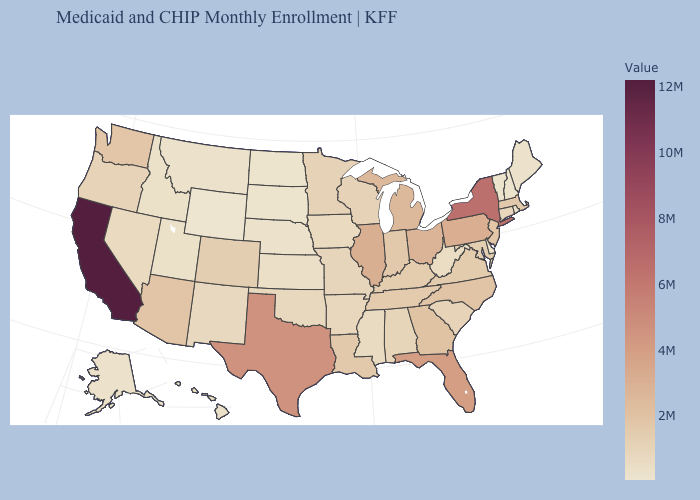Does the map have missing data?
Give a very brief answer. No. Does Arkansas have the highest value in the USA?
Answer briefly. No. Among the states that border Nevada , which have the highest value?
Answer briefly. California. Among the states that border Michigan , does Wisconsin have the lowest value?
Give a very brief answer. Yes. Does North Dakota have the highest value in the USA?
Short answer required. No. 